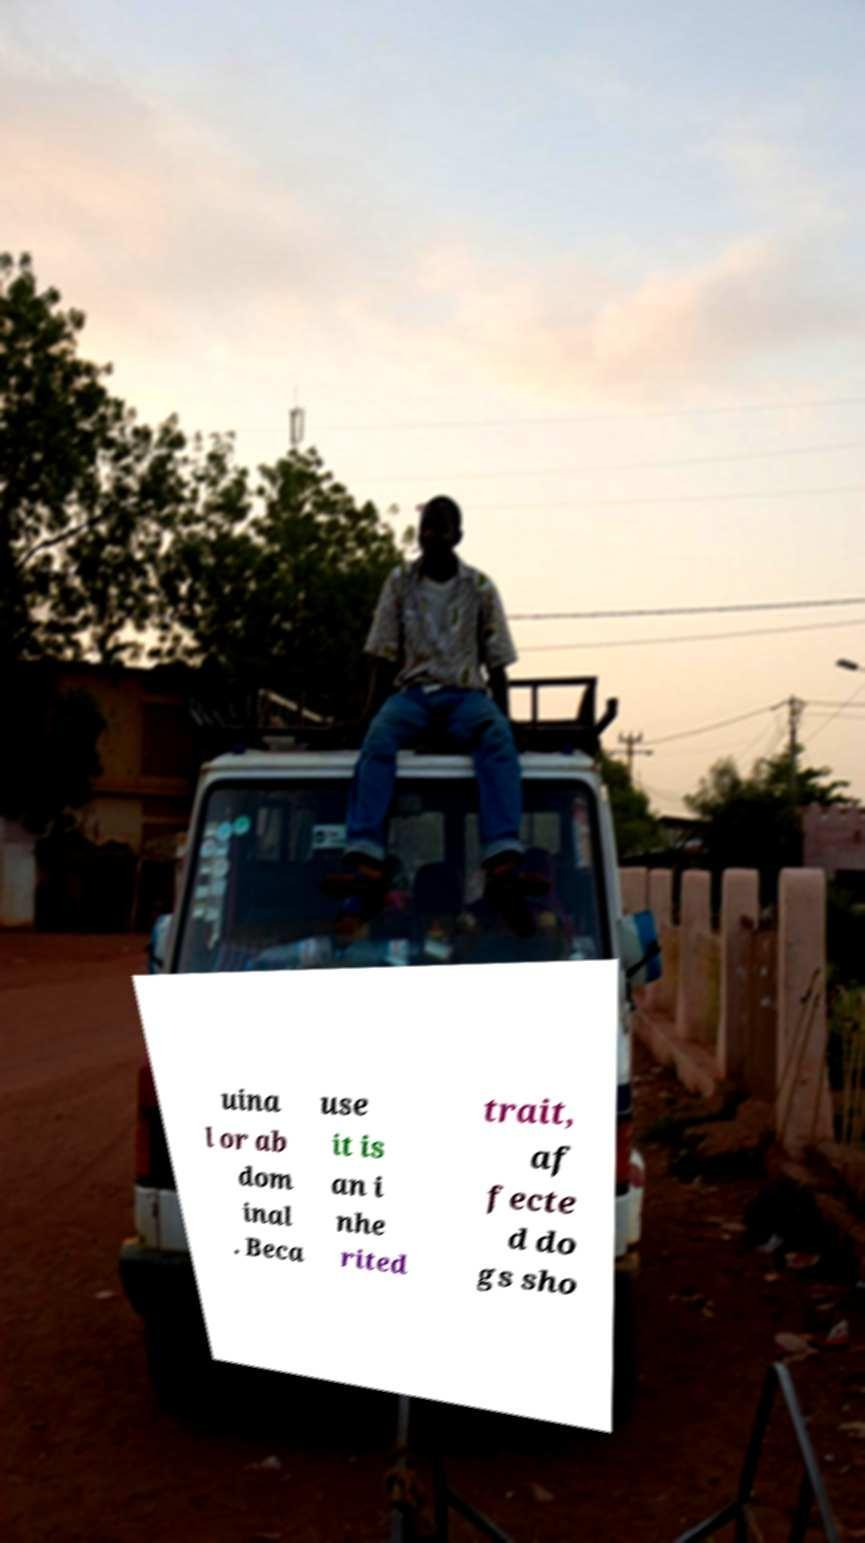What messages or text are displayed in this image? I need them in a readable, typed format. uina l or ab dom inal . Beca use it is an i nhe rited trait, af fecte d do gs sho 